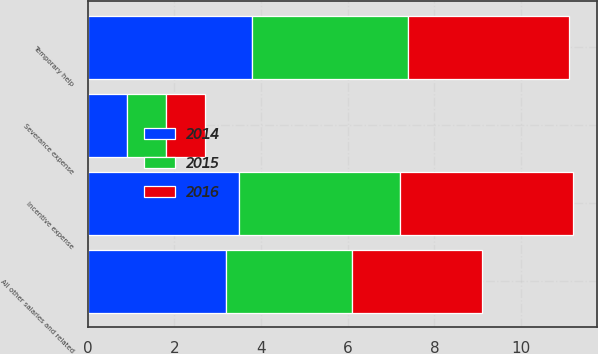Convert chart. <chart><loc_0><loc_0><loc_500><loc_500><stacked_bar_chart><ecel><fcel>Incentive expense<fcel>Severance expense<fcel>Temporary help<fcel>All other salaries and related<nl><fcel>2016<fcel>4<fcel>0.9<fcel>3.7<fcel>3<nl><fcel>2015<fcel>3.7<fcel>0.9<fcel>3.6<fcel>2.9<nl><fcel>2014<fcel>3.5<fcel>0.9<fcel>3.8<fcel>3.2<nl></chart> 